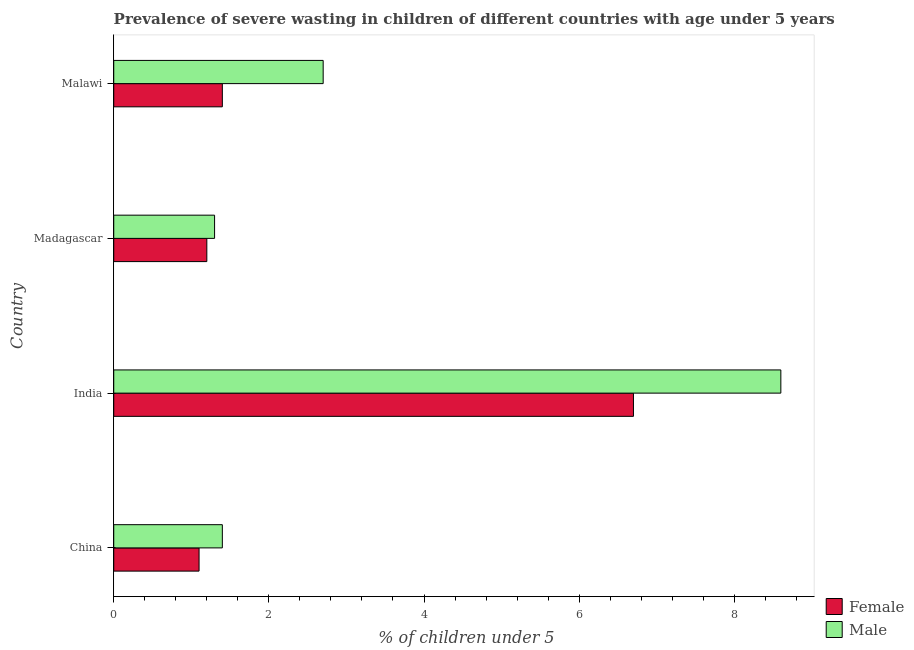How many groups of bars are there?
Keep it short and to the point. 4. How many bars are there on the 3rd tick from the bottom?
Your response must be concise. 2. What is the label of the 3rd group of bars from the top?
Make the answer very short. India. In how many cases, is the number of bars for a given country not equal to the number of legend labels?
Your answer should be very brief. 0. What is the percentage of undernourished female children in Malawi?
Make the answer very short. 1.4. Across all countries, what is the maximum percentage of undernourished female children?
Make the answer very short. 6.7. Across all countries, what is the minimum percentage of undernourished male children?
Your response must be concise. 1.3. What is the total percentage of undernourished female children in the graph?
Offer a terse response. 10.4. What is the difference between the percentage of undernourished female children in China and that in Madagascar?
Provide a succinct answer. -0.1. What is the difference between the percentage of undernourished female children in China and the percentage of undernourished male children in Madagascar?
Give a very brief answer. -0.2. In how many countries, is the percentage of undernourished male children greater than 0.8 %?
Make the answer very short. 4. What is the ratio of the percentage of undernourished female children in China to that in India?
Provide a succinct answer. 0.16. Is the difference between the percentage of undernourished female children in Madagascar and Malawi greater than the difference between the percentage of undernourished male children in Madagascar and Malawi?
Your answer should be compact. Yes. What is the difference between the highest and the second highest percentage of undernourished male children?
Make the answer very short. 5.9. What is the difference between the highest and the lowest percentage of undernourished male children?
Provide a succinct answer. 7.3. In how many countries, is the percentage of undernourished female children greater than the average percentage of undernourished female children taken over all countries?
Give a very brief answer. 1. Is the sum of the percentage of undernourished female children in China and Madagascar greater than the maximum percentage of undernourished male children across all countries?
Your answer should be compact. No. What does the 2nd bar from the bottom in Malawi represents?
Give a very brief answer. Male. How many bars are there?
Provide a short and direct response. 8. Does the graph contain any zero values?
Ensure brevity in your answer.  No. What is the title of the graph?
Your response must be concise. Prevalence of severe wasting in children of different countries with age under 5 years. What is the label or title of the X-axis?
Your response must be concise.  % of children under 5. What is the label or title of the Y-axis?
Provide a short and direct response. Country. What is the  % of children under 5 of Female in China?
Make the answer very short. 1.1. What is the  % of children under 5 of Male in China?
Keep it short and to the point. 1.4. What is the  % of children under 5 in Female in India?
Ensure brevity in your answer.  6.7. What is the  % of children under 5 in Male in India?
Keep it short and to the point. 8.6. What is the  % of children under 5 in Female in Madagascar?
Your response must be concise. 1.2. What is the  % of children under 5 in Male in Madagascar?
Offer a very short reply. 1.3. What is the  % of children under 5 of Female in Malawi?
Provide a succinct answer. 1.4. What is the  % of children under 5 in Male in Malawi?
Offer a terse response. 2.7. Across all countries, what is the maximum  % of children under 5 in Female?
Give a very brief answer. 6.7. Across all countries, what is the maximum  % of children under 5 in Male?
Provide a succinct answer. 8.6. Across all countries, what is the minimum  % of children under 5 in Female?
Offer a very short reply. 1.1. Across all countries, what is the minimum  % of children under 5 of Male?
Your response must be concise. 1.3. What is the total  % of children under 5 in Male in the graph?
Make the answer very short. 14. What is the difference between the  % of children under 5 in Female in China and that in India?
Give a very brief answer. -5.6. What is the difference between the  % of children under 5 of Male in China and that in Madagascar?
Give a very brief answer. 0.1. What is the difference between the  % of children under 5 in Female in China and that in Malawi?
Keep it short and to the point. -0.3. What is the difference between the  % of children under 5 of Male in China and that in Malawi?
Your answer should be compact. -1.3. What is the difference between the  % of children under 5 in Male in India and that in Madagascar?
Make the answer very short. 7.3. What is the difference between the  % of children under 5 of Female in Madagascar and that in Malawi?
Give a very brief answer. -0.2. What is the difference between the  % of children under 5 of Male in Madagascar and that in Malawi?
Ensure brevity in your answer.  -1.4. What is the difference between the  % of children under 5 of Female in India and the  % of children under 5 of Male in Madagascar?
Your response must be concise. 5.4. What is the difference between the  % of children under 5 in Female in Madagascar and the  % of children under 5 in Male in Malawi?
Ensure brevity in your answer.  -1.5. What is the average  % of children under 5 in Female per country?
Your answer should be compact. 2.6. What is the average  % of children under 5 in Male per country?
Your answer should be compact. 3.5. What is the difference between the  % of children under 5 of Female and  % of children under 5 of Male in India?
Give a very brief answer. -1.9. What is the difference between the  % of children under 5 in Female and  % of children under 5 in Male in Madagascar?
Provide a succinct answer. -0.1. What is the ratio of the  % of children under 5 in Female in China to that in India?
Provide a short and direct response. 0.16. What is the ratio of the  % of children under 5 of Male in China to that in India?
Provide a short and direct response. 0.16. What is the ratio of the  % of children under 5 in Female in China to that in Madagascar?
Your response must be concise. 0.92. What is the ratio of the  % of children under 5 of Female in China to that in Malawi?
Your answer should be very brief. 0.79. What is the ratio of the  % of children under 5 of Male in China to that in Malawi?
Your answer should be very brief. 0.52. What is the ratio of the  % of children under 5 in Female in India to that in Madagascar?
Give a very brief answer. 5.58. What is the ratio of the  % of children under 5 of Male in India to that in Madagascar?
Provide a short and direct response. 6.62. What is the ratio of the  % of children under 5 of Female in India to that in Malawi?
Keep it short and to the point. 4.79. What is the ratio of the  % of children under 5 of Male in India to that in Malawi?
Your response must be concise. 3.19. What is the ratio of the  % of children under 5 in Male in Madagascar to that in Malawi?
Keep it short and to the point. 0.48. What is the difference between the highest and the lowest  % of children under 5 in Female?
Give a very brief answer. 5.6. 